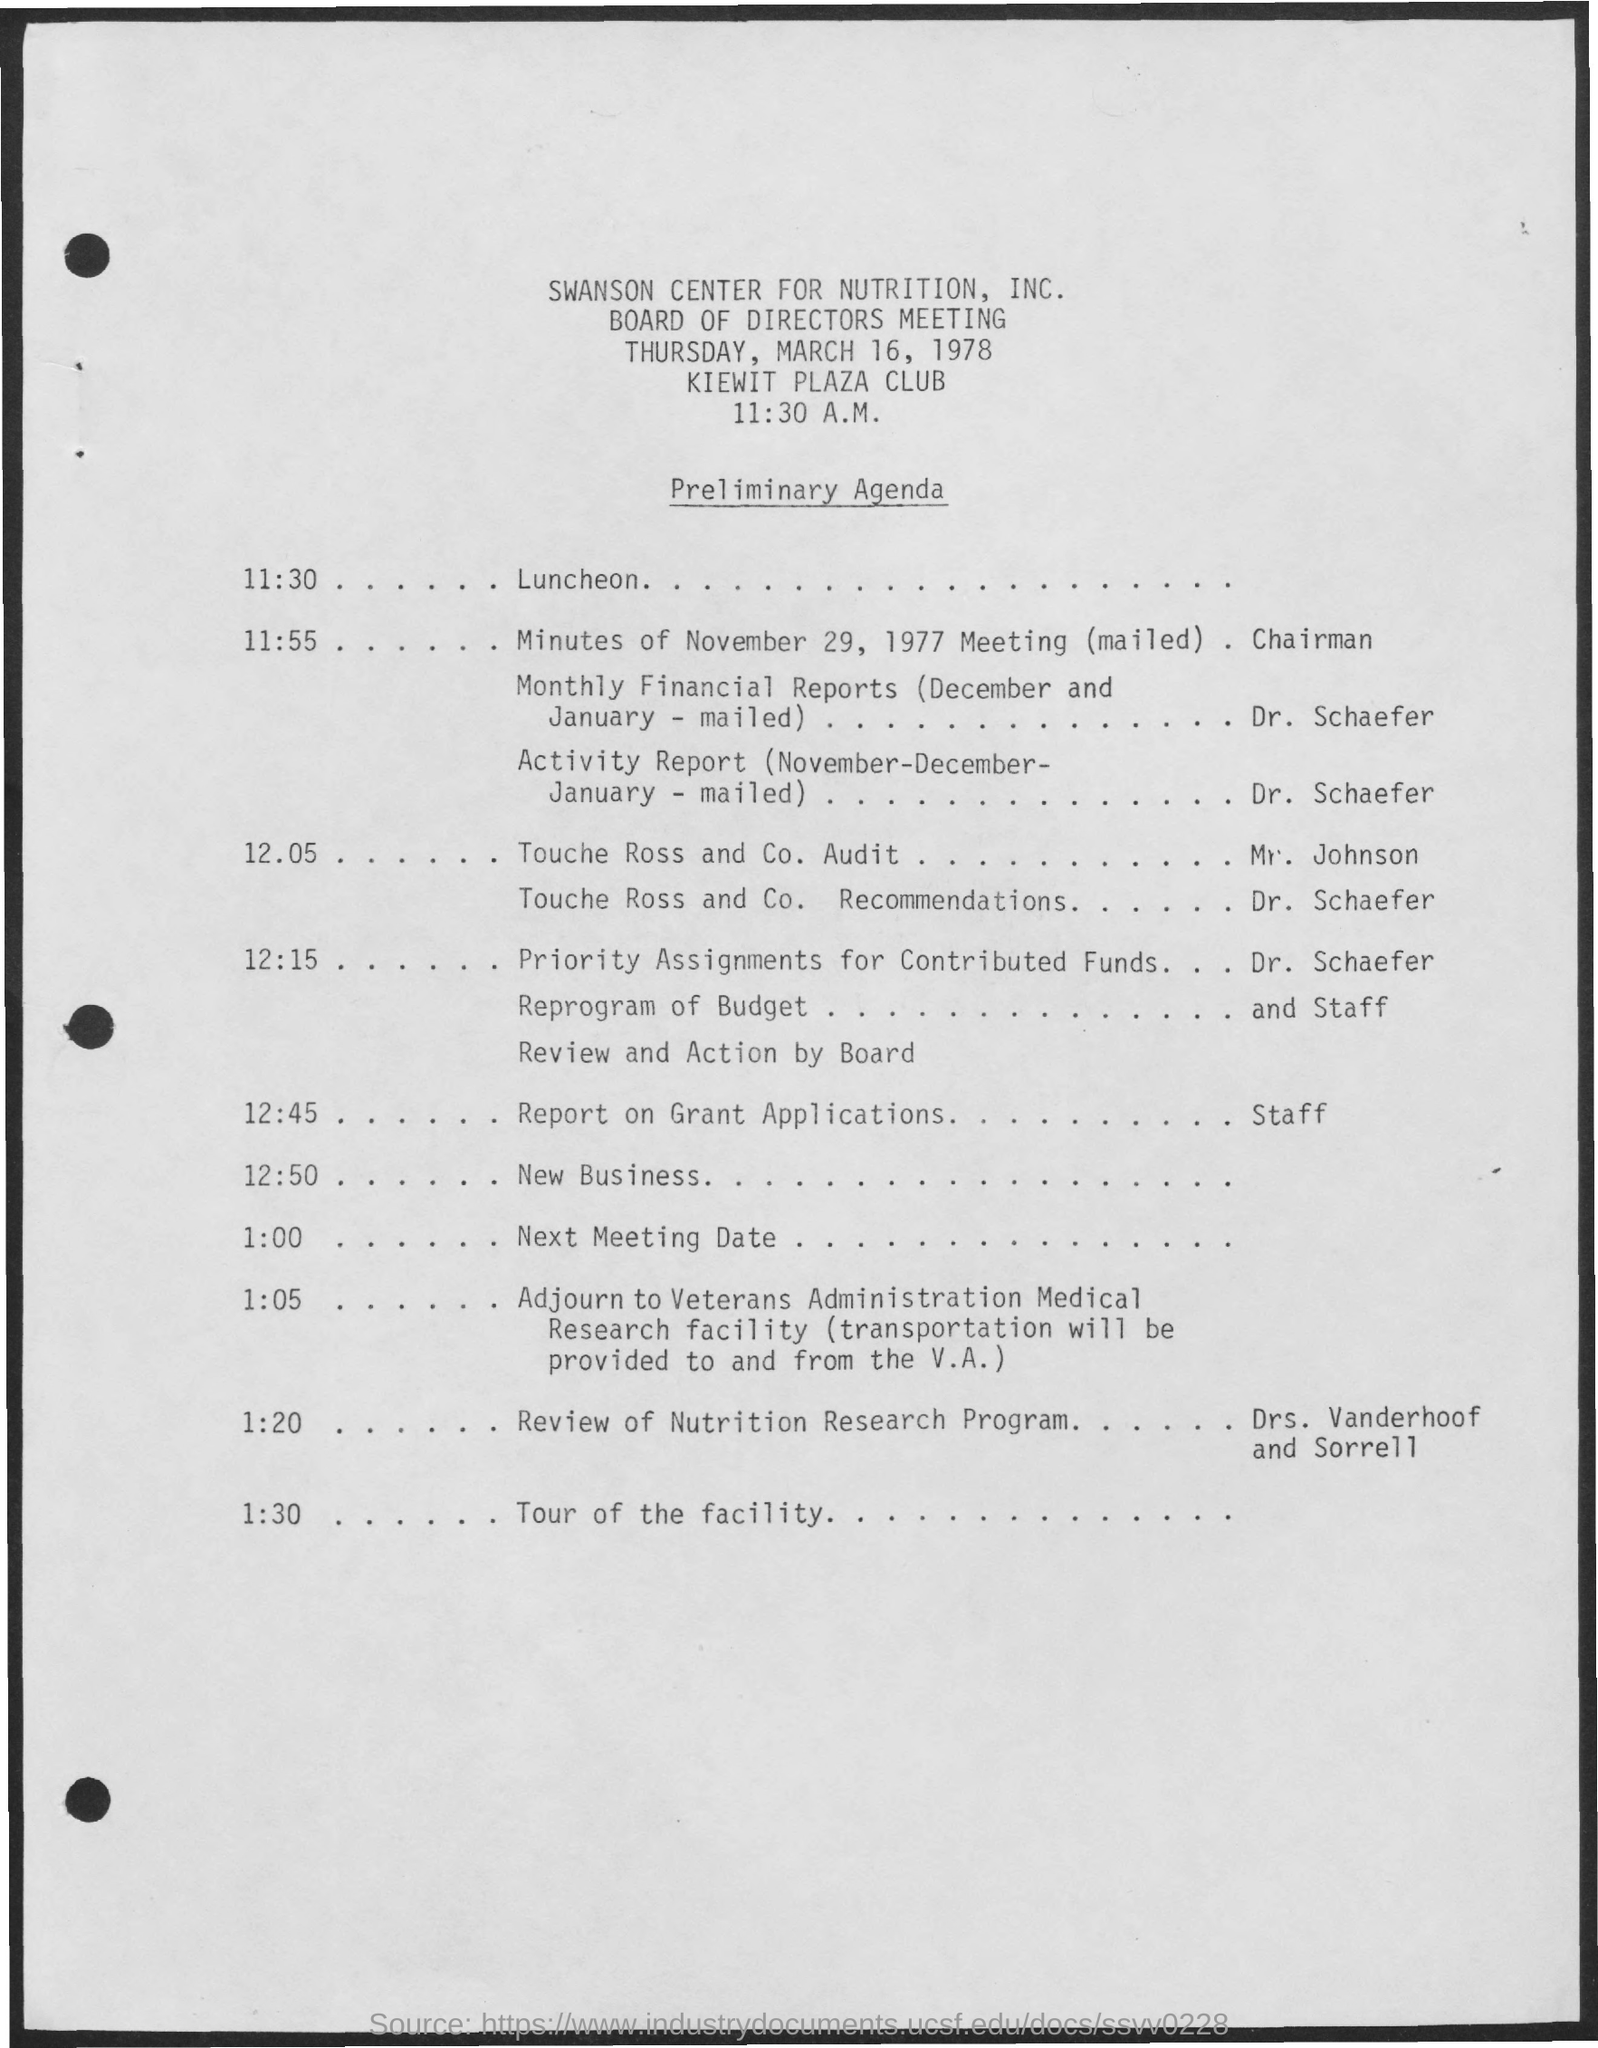Identify some key points in this picture. The board of directors meeting took place on March 16, 1978. The time mentioned in the document is 11:30 a.m. 